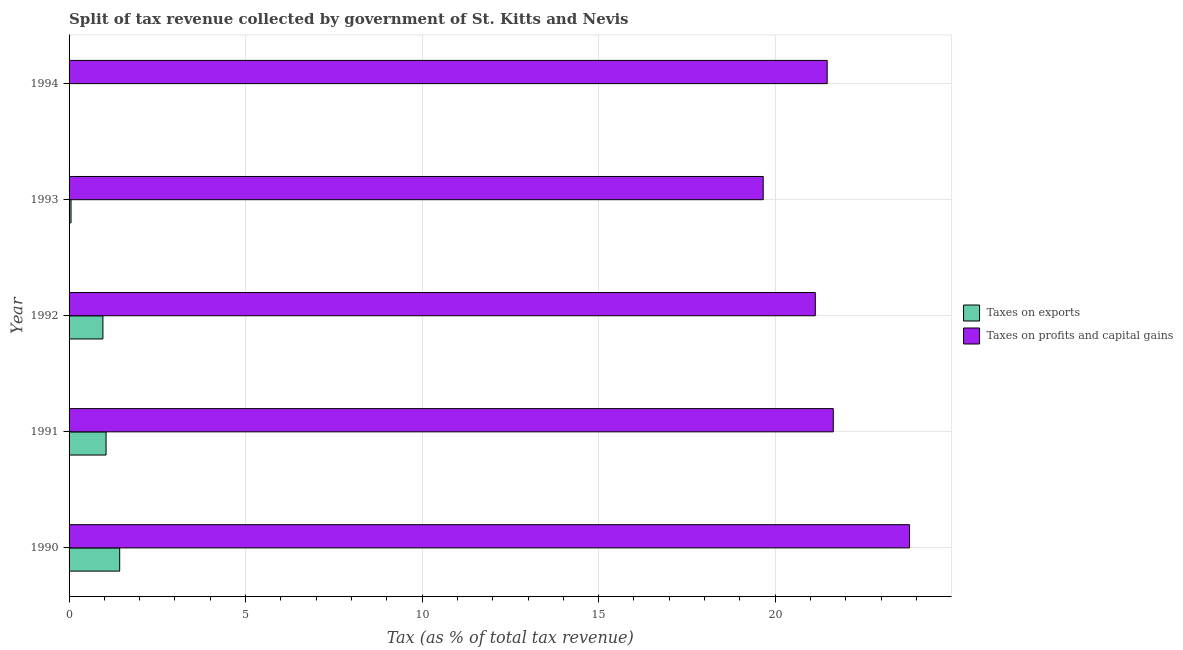How many different coloured bars are there?
Keep it short and to the point. 2. How many groups of bars are there?
Your answer should be compact. 5. Are the number of bars on each tick of the Y-axis equal?
Offer a very short reply. Yes. How many bars are there on the 5th tick from the top?
Provide a succinct answer. 2. In how many cases, is the number of bars for a given year not equal to the number of legend labels?
Provide a succinct answer. 0. What is the percentage of revenue obtained from taxes on profits and capital gains in 1990?
Offer a very short reply. 23.81. Across all years, what is the maximum percentage of revenue obtained from taxes on profits and capital gains?
Provide a succinct answer. 23.81. Across all years, what is the minimum percentage of revenue obtained from taxes on exports?
Provide a succinct answer. 0.01. In which year was the percentage of revenue obtained from taxes on profits and capital gains maximum?
Make the answer very short. 1990. What is the total percentage of revenue obtained from taxes on exports in the graph?
Make the answer very short. 3.5. What is the difference between the percentage of revenue obtained from taxes on profits and capital gains in 1990 and that in 1994?
Your answer should be compact. 2.33. What is the difference between the percentage of revenue obtained from taxes on exports in 1990 and the percentage of revenue obtained from taxes on profits and capital gains in 1991?
Make the answer very short. -20.21. What is the average percentage of revenue obtained from taxes on profits and capital gains per year?
Offer a terse response. 21.55. In the year 1993, what is the difference between the percentage of revenue obtained from taxes on exports and percentage of revenue obtained from taxes on profits and capital gains?
Give a very brief answer. -19.61. What is the ratio of the percentage of revenue obtained from taxes on profits and capital gains in 1992 to that in 1994?
Make the answer very short. 0.98. Is the difference between the percentage of revenue obtained from taxes on profits and capital gains in 1992 and 1993 greater than the difference between the percentage of revenue obtained from taxes on exports in 1992 and 1993?
Offer a terse response. Yes. What is the difference between the highest and the second highest percentage of revenue obtained from taxes on profits and capital gains?
Give a very brief answer. 2.16. What is the difference between the highest and the lowest percentage of revenue obtained from taxes on profits and capital gains?
Give a very brief answer. 4.14. In how many years, is the percentage of revenue obtained from taxes on exports greater than the average percentage of revenue obtained from taxes on exports taken over all years?
Provide a succinct answer. 3. What does the 1st bar from the top in 1990 represents?
Your response must be concise. Taxes on profits and capital gains. What does the 2nd bar from the bottom in 1992 represents?
Your answer should be compact. Taxes on profits and capital gains. What is the difference between two consecutive major ticks on the X-axis?
Keep it short and to the point. 5. How many legend labels are there?
Make the answer very short. 2. What is the title of the graph?
Ensure brevity in your answer.  Split of tax revenue collected by government of St. Kitts and Nevis. What is the label or title of the X-axis?
Give a very brief answer. Tax (as % of total tax revenue). What is the label or title of the Y-axis?
Your answer should be compact. Year. What is the Tax (as % of total tax revenue) in Taxes on exports in 1990?
Give a very brief answer. 1.43. What is the Tax (as % of total tax revenue) in Taxes on profits and capital gains in 1990?
Provide a succinct answer. 23.81. What is the Tax (as % of total tax revenue) of Taxes on exports in 1991?
Your response must be concise. 1.05. What is the Tax (as % of total tax revenue) of Taxes on profits and capital gains in 1991?
Provide a succinct answer. 21.65. What is the Tax (as % of total tax revenue) in Taxes on exports in 1992?
Ensure brevity in your answer.  0.96. What is the Tax (as % of total tax revenue) in Taxes on profits and capital gains in 1992?
Keep it short and to the point. 21.14. What is the Tax (as % of total tax revenue) in Taxes on exports in 1993?
Your response must be concise. 0.06. What is the Tax (as % of total tax revenue) of Taxes on profits and capital gains in 1993?
Keep it short and to the point. 19.66. What is the Tax (as % of total tax revenue) in Taxes on exports in 1994?
Give a very brief answer. 0.01. What is the Tax (as % of total tax revenue) in Taxes on profits and capital gains in 1994?
Provide a succinct answer. 21.47. Across all years, what is the maximum Tax (as % of total tax revenue) of Taxes on exports?
Ensure brevity in your answer.  1.43. Across all years, what is the maximum Tax (as % of total tax revenue) of Taxes on profits and capital gains?
Your answer should be very brief. 23.81. Across all years, what is the minimum Tax (as % of total tax revenue) in Taxes on exports?
Make the answer very short. 0.01. Across all years, what is the minimum Tax (as % of total tax revenue) in Taxes on profits and capital gains?
Keep it short and to the point. 19.66. What is the total Tax (as % of total tax revenue) of Taxes on exports in the graph?
Offer a terse response. 3.5. What is the total Tax (as % of total tax revenue) in Taxes on profits and capital gains in the graph?
Offer a very short reply. 107.73. What is the difference between the Tax (as % of total tax revenue) in Taxes on exports in 1990 and that in 1991?
Your response must be concise. 0.39. What is the difference between the Tax (as % of total tax revenue) of Taxes on profits and capital gains in 1990 and that in 1991?
Keep it short and to the point. 2.16. What is the difference between the Tax (as % of total tax revenue) of Taxes on exports in 1990 and that in 1992?
Your answer should be very brief. 0.48. What is the difference between the Tax (as % of total tax revenue) of Taxes on profits and capital gains in 1990 and that in 1992?
Make the answer very short. 2.67. What is the difference between the Tax (as % of total tax revenue) in Taxes on exports in 1990 and that in 1993?
Give a very brief answer. 1.38. What is the difference between the Tax (as % of total tax revenue) in Taxes on profits and capital gains in 1990 and that in 1993?
Your answer should be compact. 4.14. What is the difference between the Tax (as % of total tax revenue) of Taxes on exports in 1990 and that in 1994?
Offer a very short reply. 1.43. What is the difference between the Tax (as % of total tax revenue) of Taxes on profits and capital gains in 1990 and that in 1994?
Your answer should be compact. 2.33. What is the difference between the Tax (as % of total tax revenue) in Taxes on exports in 1991 and that in 1992?
Keep it short and to the point. 0.09. What is the difference between the Tax (as % of total tax revenue) of Taxes on profits and capital gains in 1991 and that in 1992?
Provide a short and direct response. 0.51. What is the difference between the Tax (as % of total tax revenue) in Taxes on exports in 1991 and that in 1993?
Provide a succinct answer. 0.99. What is the difference between the Tax (as % of total tax revenue) in Taxes on profits and capital gains in 1991 and that in 1993?
Your response must be concise. 1.98. What is the difference between the Tax (as % of total tax revenue) in Taxes on exports in 1991 and that in 1994?
Provide a short and direct response. 1.04. What is the difference between the Tax (as % of total tax revenue) of Taxes on profits and capital gains in 1991 and that in 1994?
Offer a terse response. 0.17. What is the difference between the Tax (as % of total tax revenue) in Taxes on exports in 1992 and that in 1993?
Your answer should be compact. 0.9. What is the difference between the Tax (as % of total tax revenue) of Taxes on profits and capital gains in 1992 and that in 1993?
Your response must be concise. 1.48. What is the difference between the Tax (as % of total tax revenue) in Taxes on exports in 1992 and that in 1994?
Give a very brief answer. 0.95. What is the difference between the Tax (as % of total tax revenue) in Taxes on profits and capital gains in 1992 and that in 1994?
Provide a succinct answer. -0.34. What is the difference between the Tax (as % of total tax revenue) of Taxes on exports in 1993 and that in 1994?
Offer a very short reply. 0.05. What is the difference between the Tax (as % of total tax revenue) in Taxes on profits and capital gains in 1993 and that in 1994?
Your answer should be very brief. -1.81. What is the difference between the Tax (as % of total tax revenue) of Taxes on exports in 1990 and the Tax (as % of total tax revenue) of Taxes on profits and capital gains in 1991?
Offer a terse response. -20.21. What is the difference between the Tax (as % of total tax revenue) in Taxes on exports in 1990 and the Tax (as % of total tax revenue) in Taxes on profits and capital gains in 1992?
Ensure brevity in your answer.  -19.7. What is the difference between the Tax (as % of total tax revenue) of Taxes on exports in 1990 and the Tax (as % of total tax revenue) of Taxes on profits and capital gains in 1993?
Ensure brevity in your answer.  -18.23. What is the difference between the Tax (as % of total tax revenue) in Taxes on exports in 1990 and the Tax (as % of total tax revenue) in Taxes on profits and capital gains in 1994?
Give a very brief answer. -20.04. What is the difference between the Tax (as % of total tax revenue) in Taxes on exports in 1991 and the Tax (as % of total tax revenue) in Taxes on profits and capital gains in 1992?
Keep it short and to the point. -20.09. What is the difference between the Tax (as % of total tax revenue) in Taxes on exports in 1991 and the Tax (as % of total tax revenue) in Taxes on profits and capital gains in 1993?
Your response must be concise. -18.61. What is the difference between the Tax (as % of total tax revenue) of Taxes on exports in 1991 and the Tax (as % of total tax revenue) of Taxes on profits and capital gains in 1994?
Your response must be concise. -20.43. What is the difference between the Tax (as % of total tax revenue) of Taxes on exports in 1992 and the Tax (as % of total tax revenue) of Taxes on profits and capital gains in 1993?
Your response must be concise. -18.7. What is the difference between the Tax (as % of total tax revenue) of Taxes on exports in 1992 and the Tax (as % of total tax revenue) of Taxes on profits and capital gains in 1994?
Your answer should be compact. -20.51. What is the difference between the Tax (as % of total tax revenue) of Taxes on exports in 1993 and the Tax (as % of total tax revenue) of Taxes on profits and capital gains in 1994?
Provide a short and direct response. -21.42. What is the average Tax (as % of total tax revenue) in Taxes on exports per year?
Make the answer very short. 0.7. What is the average Tax (as % of total tax revenue) of Taxes on profits and capital gains per year?
Give a very brief answer. 21.55. In the year 1990, what is the difference between the Tax (as % of total tax revenue) in Taxes on exports and Tax (as % of total tax revenue) in Taxes on profits and capital gains?
Keep it short and to the point. -22.37. In the year 1991, what is the difference between the Tax (as % of total tax revenue) in Taxes on exports and Tax (as % of total tax revenue) in Taxes on profits and capital gains?
Provide a succinct answer. -20.6. In the year 1992, what is the difference between the Tax (as % of total tax revenue) of Taxes on exports and Tax (as % of total tax revenue) of Taxes on profits and capital gains?
Keep it short and to the point. -20.18. In the year 1993, what is the difference between the Tax (as % of total tax revenue) of Taxes on exports and Tax (as % of total tax revenue) of Taxes on profits and capital gains?
Provide a succinct answer. -19.61. In the year 1994, what is the difference between the Tax (as % of total tax revenue) of Taxes on exports and Tax (as % of total tax revenue) of Taxes on profits and capital gains?
Make the answer very short. -21.46. What is the ratio of the Tax (as % of total tax revenue) of Taxes on exports in 1990 to that in 1991?
Ensure brevity in your answer.  1.37. What is the ratio of the Tax (as % of total tax revenue) of Taxes on profits and capital gains in 1990 to that in 1991?
Ensure brevity in your answer.  1.1. What is the ratio of the Tax (as % of total tax revenue) of Taxes on exports in 1990 to that in 1992?
Provide a succinct answer. 1.5. What is the ratio of the Tax (as % of total tax revenue) in Taxes on profits and capital gains in 1990 to that in 1992?
Your answer should be compact. 1.13. What is the ratio of the Tax (as % of total tax revenue) in Taxes on exports in 1990 to that in 1993?
Keep it short and to the point. 25.86. What is the ratio of the Tax (as % of total tax revenue) in Taxes on profits and capital gains in 1990 to that in 1993?
Offer a terse response. 1.21. What is the ratio of the Tax (as % of total tax revenue) in Taxes on exports in 1990 to that in 1994?
Provide a succinct answer. 174.21. What is the ratio of the Tax (as % of total tax revenue) of Taxes on profits and capital gains in 1990 to that in 1994?
Keep it short and to the point. 1.11. What is the ratio of the Tax (as % of total tax revenue) of Taxes on exports in 1991 to that in 1992?
Provide a succinct answer. 1.09. What is the ratio of the Tax (as % of total tax revenue) of Taxes on profits and capital gains in 1991 to that in 1992?
Ensure brevity in your answer.  1.02. What is the ratio of the Tax (as % of total tax revenue) of Taxes on exports in 1991 to that in 1993?
Make the answer very short. 18.9. What is the ratio of the Tax (as % of total tax revenue) in Taxes on profits and capital gains in 1991 to that in 1993?
Offer a very short reply. 1.1. What is the ratio of the Tax (as % of total tax revenue) in Taxes on exports in 1991 to that in 1994?
Your answer should be very brief. 127.31. What is the ratio of the Tax (as % of total tax revenue) in Taxes on profits and capital gains in 1991 to that in 1994?
Your answer should be very brief. 1.01. What is the ratio of the Tax (as % of total tax revenue) in Taxes on exports in 1992 to that in 1993?
Your response must be concise. 17.29. What is the ratio of the Tax (as % of total tax revenue) of Taxes on profits and capital gains in 1992 to that in 1993?
Provide a succinct answer. 1.07. What is the ratio of the Tax (as % of total tax revenue) in Taxes on exports in 1992 to that in 1994?
Provide a succinct answer. 116.45. What is the ratio of the Tax (as % of total tax revenue) of Taxes on profits and capital gains in 1992 to that in 1994?
Make the answer very short. 0.98. What is the ratio of the Tax (as % of total tax revenue) in Taxes on exports in 1993 to that in 1994?
Provide a succinct answer. 6.74. What is the ratio of the Tax (as % of total tax revenue) of Taxes on profits and capital gains in 1993 to that in 1994?
Your answer should be very brief. 0.92. What is the difference between the highest and the second highest Tax (as % of total tax revenue) of Taxes on exports?
Your response must be concise. 0.39. What is the difference between the highest and the second highest Tax (as % of total tax revenue) of Taxes on profits and capital gains?
Your response must be concise. 2.16. What is the difference between the highest and the lowest Tax (as % of total tax revenue) in Taxes on exports?
Offer a very short reply. 1.43. What is the difference between the highest and the lowest Tax (as % of total tax revenue) in Taxes on profits and capital gains?
Give a very brief answer. 4.14. 